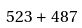Convert formula to latex. <formula><loc_0><loc_0><loc_500><loc_500>5 2 3 + 4 8 7</formula> 